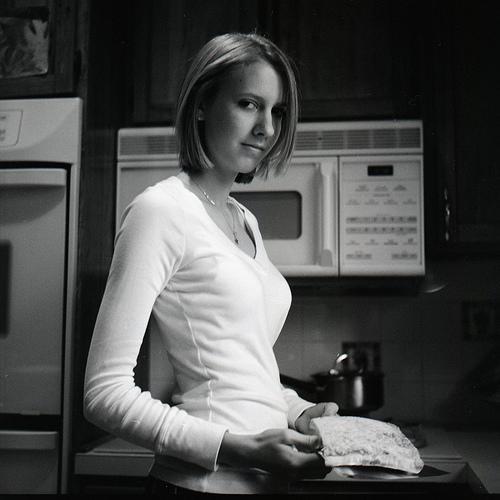Is "The pizza is touching the person." an appropriate description for the image?
Answer yes or no. Yes. 